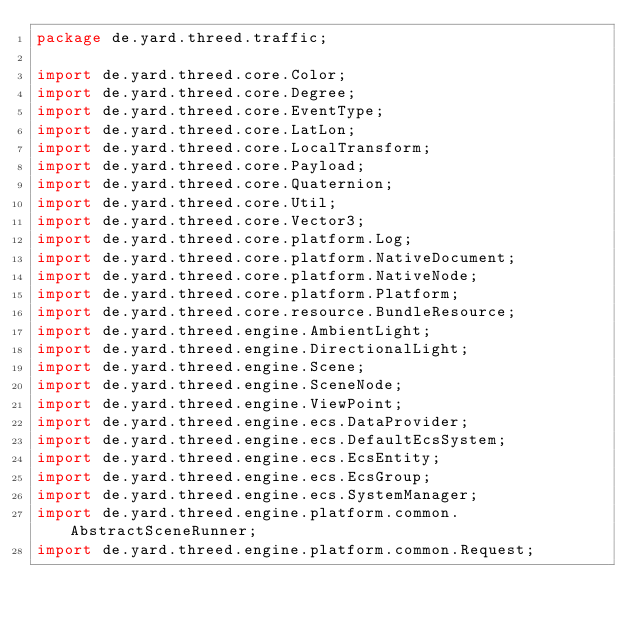<code> <loc_0><loc_0><loc_500><loc_500><_Java_>package de.yard.threed.traffic;

import de.yard.threed.core.Color;
import de.yard.threed.core.Degree;
import de.yard.threed.core.EventType;
import de.yard.threed.core.LatLon;
import de.yard.threed.core.LocalTransform;
import de.yard.threed.core.Payload;
import de.yard.threed.core.Quaternion;
import de.yard.threed.core.Util;
import de.yard.threed.core.Vector3;
import de.yard.threed.core.platform.Log;
import de.yard.threed.core.platform.NativeDocument;
import de.yard.threed.core.platform.NativeNode;
import de.yard.threed.core.platform.Platform;
import de.yard.threed.core.resource.BundleResource;
import de.yard.threed.engine.AmbientLight;
import de.yard.threed.engine.DirectionalLight;
import de.yard.threed.engine.Scene;
import de.yard.threed.engine.SceneNode;
import de.yard.threed.engine.ViewPoint;
import de.yard.threed.engine.ecs.DataProvider;
import de.yard.threed.engine.ecs.DefaultEcsSystem;
import de.yard.threed.engine.ecs.EcsEntity;
import de.yard.threed.engine.ecs.EcsGroup;
import de.yard.threed.engine.ecs.SystemManager;
import de.yard.threed.engine.platform.common.AbstractSceneRunner;
import de.yard.threed.engine.platform.common.Request;</code> 